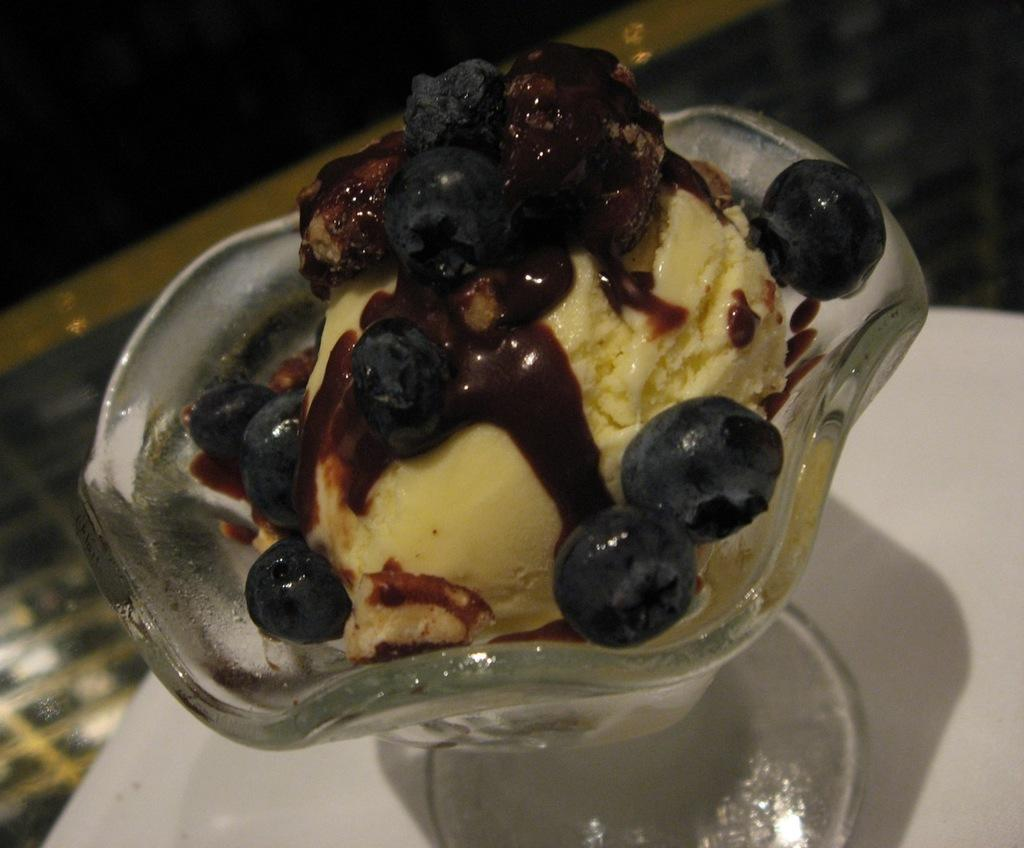What is the main subject of the image? The main subject of the image is an ice cream. How is the ice cream contained in the image? The ice cream is in a bowl. Where is the bowl placed in the image? The bowl is on a surface. What is the color of the surface? The surface is white in color. What type of meal is being prepared on the white surface in the image? There is no meal being prepared in the image; it only shows an ice cream in a bowl on a white surface. 